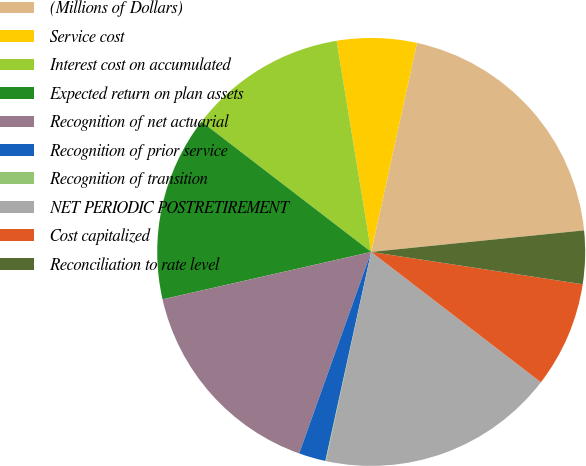Convert chart to OTSL. <chart><loc_0><loc_0><loc_500><loc_500><pie_chart><fcel>(Millions of Dollars)<fcel>Service cost<fcel>Interest cost on accumulated<fcel>Expected return on plan assets<fcel>Recognition of net actuarial<fcel>Recognition of prior service<fcel>Recognition of transition<fcel>NET PERIODIC POSTRETIREMENT<fcel>Cost capitalized<fcel>Reconciliation to rate level<nl><fcel>19.96%<fcel>6.02%<fcel>11.99%<fcel>13.98%<fcel>15.98%<fcel>2.03%<fcel>0.04%<fcel>17.97%<fcel>8.01%<fcel>4.02%<nl></chart> 